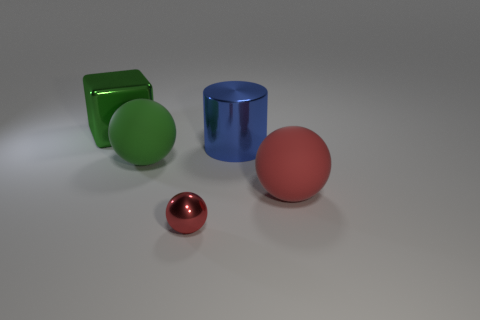Add 5 big purple blocks. How many objects exist? 10 Subtract all cylinders. How many objects are left? 4 Subtract 1 green cubes. How many objects are left? 4 Subtract all big green matte spheres. Subtract all large matte objects. How many objects are left? 2 Add 1 large red rubber balls. How many large red rubber balls are left? 2 Add 1 red rubber cubes. How many red rubber cubes exist? 1 